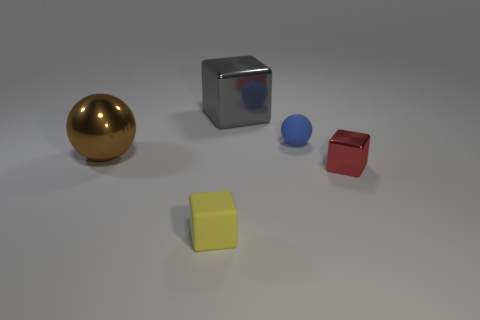Subtract all metal blocks. How many blocks are left? 1 Add 1 small gray matte cylinders. How many objects exist? 6 Subtract all brown cubes. Subtract all brown cylinders. How many cubes are left? 3 Subtract all cubes. How many objects are left? 2 Add 4 big yellow rubber cylinders. How many big yellow rubber cylinders exist? 4 Subtract 0 purple cylinders. How many objects are left? 5 Subtract all tiny brown shiny balls. Subtract all tiny blue matte things. How many objects are left? 4 Add 4 small yellow objects. How many small yellow objects are left? 5 